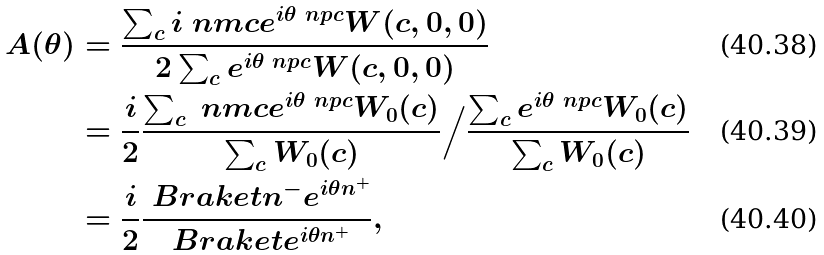<formula> <loc_0><loc_0><loc_500><loc_500>A ( \theta ) & = \frac { \sum _ { c } i \ n m c e ^ { i \theta \ n p c } W ( c , 0 , 0 ) } { 2 \sum _ { c } e ^ { i \theta \ n p c } W ( c , 0 , 0 ) } \\ & = \frac { i } { 2 } \frac { \sum _ { c } \ n m c e ^ { i \theta \ n p c } W _ { 0 } ( c ) } { \sum _ { c } W _ { 0 } ( c ) } \Big / \frac { \sum _ { c } e ^ { i \theta \ n p c } W _ { 0 } ( c ) } { \sum _ { c } W _ { 0 } ( c ) } \\ & = \frac { i } { 2 } \frac { \ B r a k e t { n ^ { - } e ^ { i \theta n ^ { + } } } } { \ B r a k e t { e ^ { i \theta n ^ { + } } } } ,</formula> 